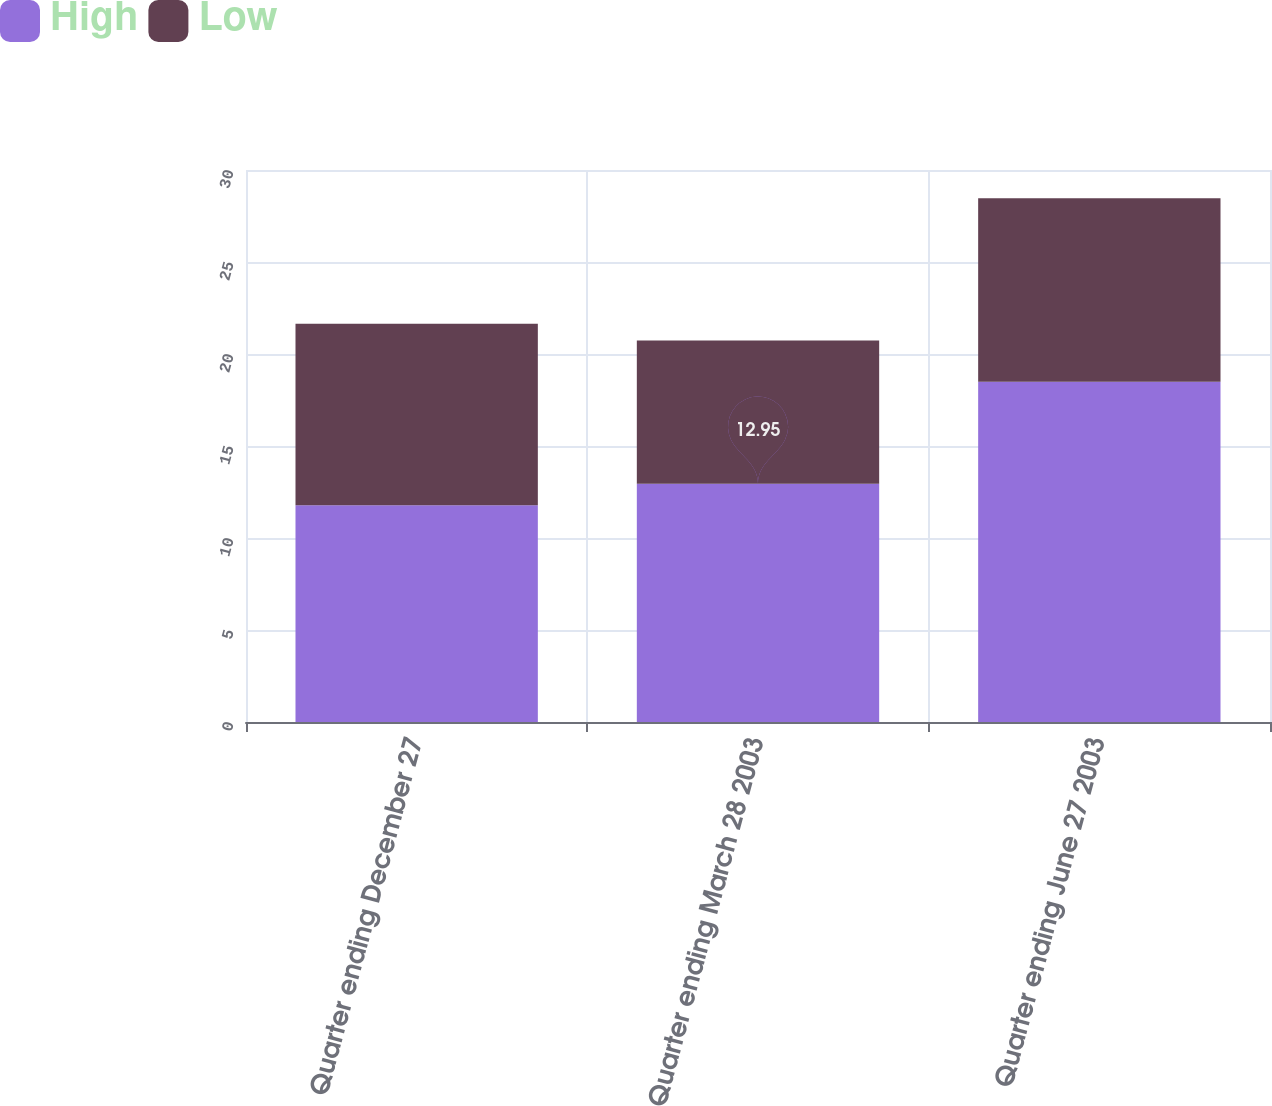<chart> <loc_0><loc_0><loc_500><loc_500><stacked_bar_chart><ecel><fcel>Quarter ending December 27<fcel>Quarter ending March 28 2003<fcel>Quarter ending June 27 2003<nl><fcel>High<fcel>11.78<fcel>12.95<fcel>18.49<nl><fcel>Low<fcel>9.86<fcel>7.78<fcel>9.98<nl></chart> 